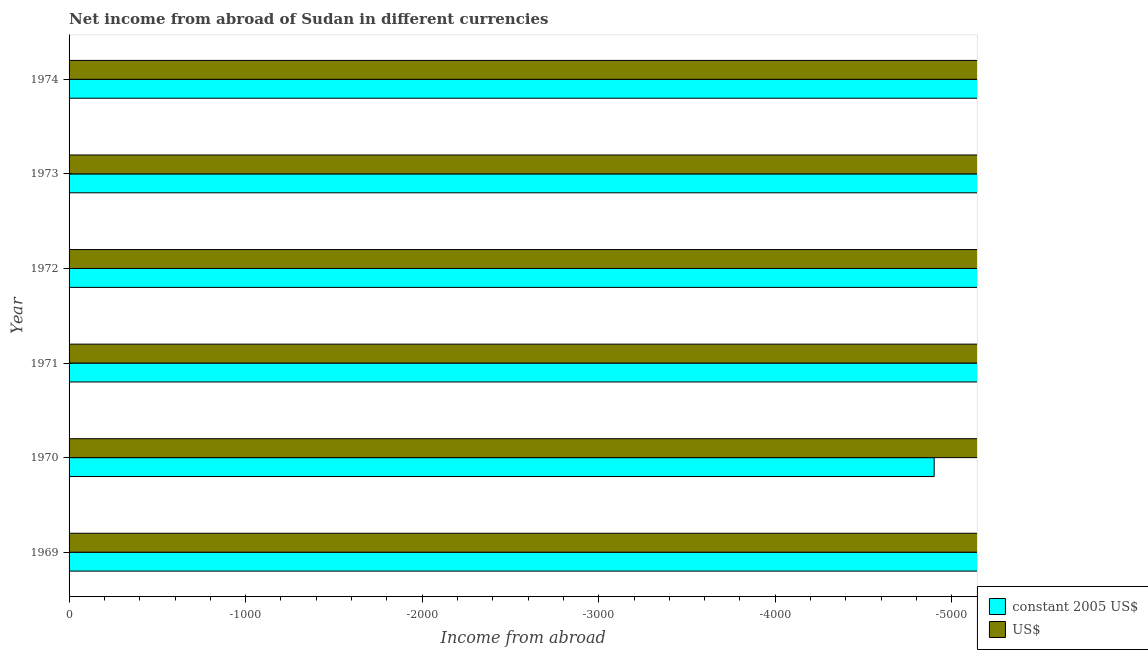How many bars are there on the 3rd tick from the top?
Ensure brevity in your answer.  0. How many bars are there on the 3rd tick from the bottom?
Keep it short and to the point. 0. What is the label of the 5th group of bars from the top?
Provide a succinct answer. 1970. In how many cases, is the number of bars for a given year not equal to the number of legend labels?
Keep it short and to the point. 6. What is the income from abroad in us$ in 1972?
Your answer should be very brief. 0. Across all years, what is the minimum income from abroad in us$?
Make the answer very short. 0. What is the difference between the income from abroad in constant 2005 us$ in 1974 and the income from abroad in us$ in 1971?
Keep it short and to the point. 0. In how many years, is the income from abroad in us$ greater than -200 units?
Offer a terse response. 0. In how many years, is the income from abroad in constant 2005 us$ greater than the average income from abroad in constant 2005 us$ taken over all years?
Give a very brief answer. 0. How many bars are there?
Your answer should be very brief. 0. Are all the bars in the graph horizontal?
Your response must be concise. Yes. Are the values on the major ticks of X-axis written in scientific E-notation?
Give a very brief answer. No. Does the graph contain any zero values?
Provide a succinct answer. Yes. Does the graph contain grids?
Your answer should be compact. No. Where does the legend appear in the graph?
Provide a succinct answer. Bottom right. How many legend labels are there?
Your answer should be compact. 2. How are the legend labels stacked?
Make the answer very short. Vertical. What is the title of the graph?
Make the answer very short. Net income from abroad of Sudan in different currencies. Does "ODA received" appear as one of the legend labels in the graph?
Your response must be concise. No. What is the label or title of the X-axis?
Ensure brevity in your answer.  Income from abroad. What is the Income from abroad of constant 2005 US$ in 1970?
Provide a succinct answer. 0. What is the Income from abroad in US$ in 1970?
Offer a very short reply. 0. What is the Income from abroad of constant 2005 US$ in 1971?
Offer a very short reply. 0. What is the Income from abroad of US$ in 1973?
Ensure brevity in your answer.  0. What is the Income from abroad of US$ in 1974?
Your answer should be very brief. 0. What is the total Income from abroad of US$ in the graph?
Provide a short and direct response. 0. 